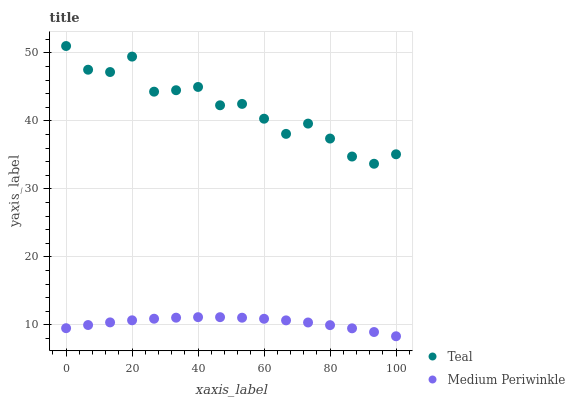Does Medium Periwinkle have the minimum area under the curve?
Answer yes or no. Yes. Does Teal have the maximum area under the curve?
Answer yes or no. Yes. Does Teal have the minimum area under the curve?
Answer yes or no. No. Is Medium Periwinkle the smoothest?
Answer yes or no. Yes. Is Teal the roughest?
Answer yes or no. Yes. Is Teal the smoothest?
Answer yes or no. No. Does Medium Periwinkle have the lowest value?
Answer yes or no. Yes. Does Teal have the lowest value?
Answer yes or no. No. Does Teal have the highest value?
Answer yes or no. Yes. Is Medium Periwinkle less than Teal?
Answer yes or no. Yes. Is Teal greater than Medium Periwinkle?
Answer yes or no. Yes. Does Medium Periwinkle intersect Teal?
Answer yes or no. No. 